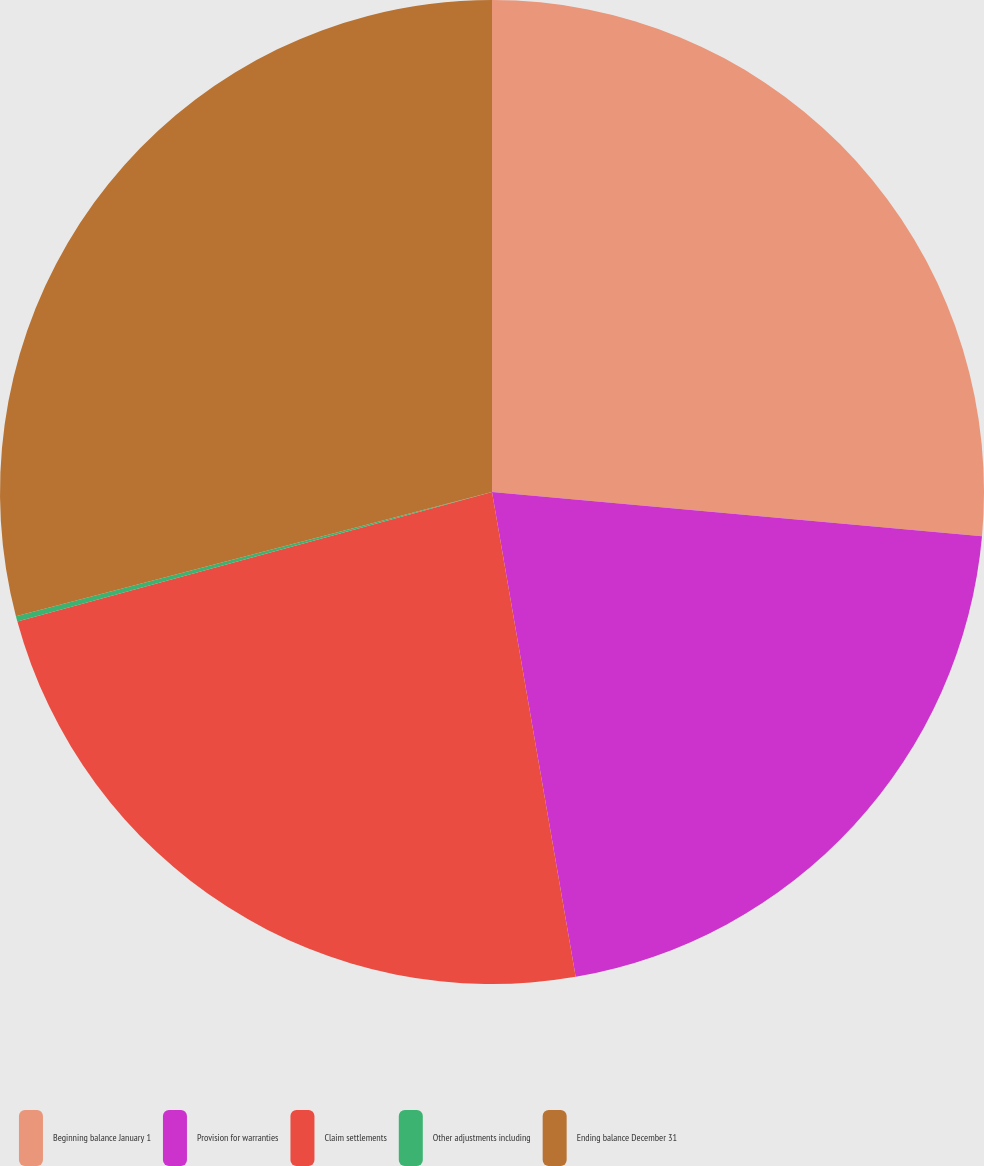Convert chart to OTSL. <chart><loc_0><loc_0><loc_500><loc_500><pie_chart><fcel>Beginning balance January 1<fcel>Provision for warranties<fcel>Claim settlements<fcel>Other adjustments including<fcel>Ending balance December 31<nl><fcel>26.43%<fcel>20.85%<fcel>23.48%<fcel>0.18%<fcel>29.06%<nl></chart> 